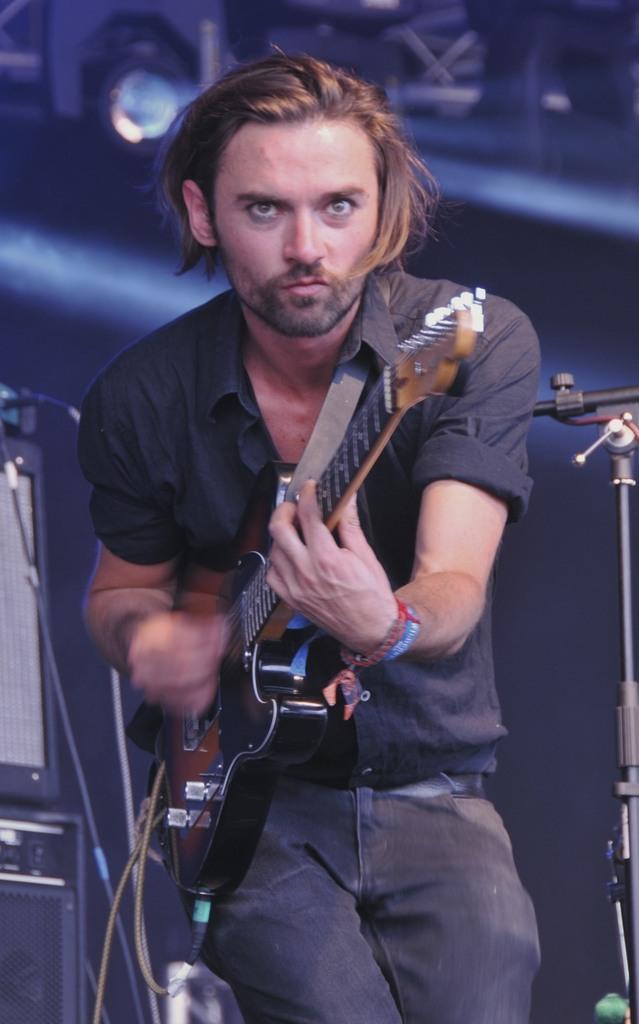Could you give a brief overview of what you see in this image? This picture shows a man standing and playing a guitar 